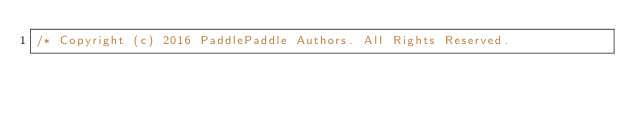<code> <loc_0><loc_0><loc_500><loc_500><_C++_>/* Copyright (c) 2016 PaddlePaddle Authors. All Rights Reserved.
</code> 